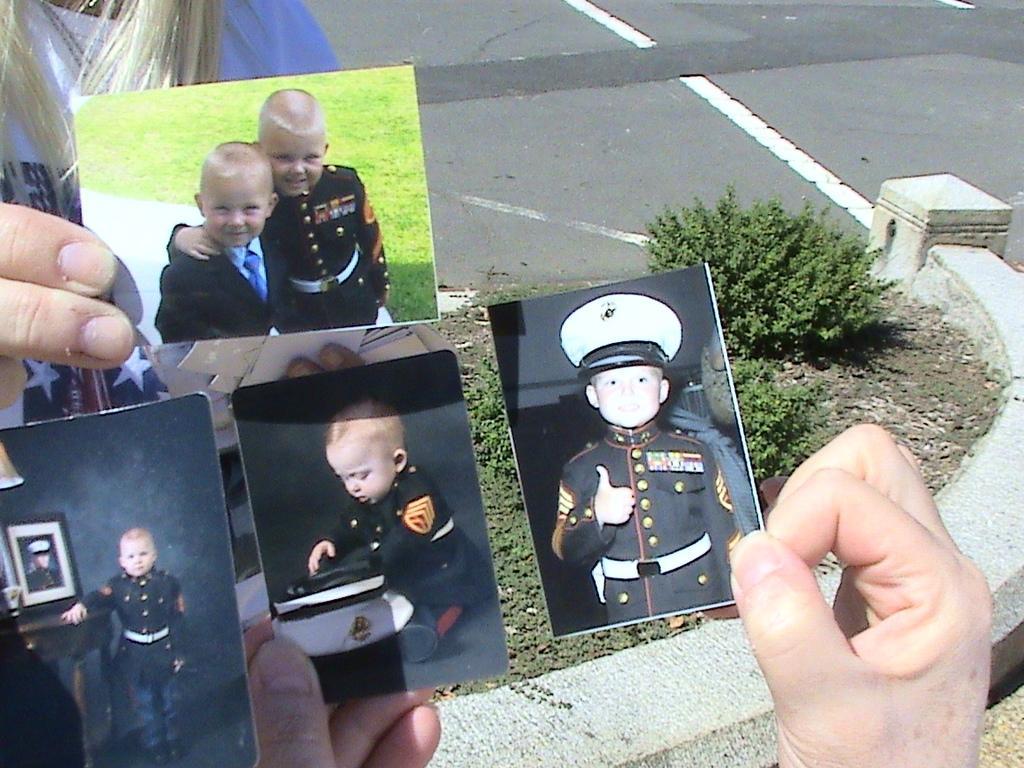Could you give a brief overview of what you see in this image? In this image there are two persons holding photographs of children in their hands, on the surface we can see baby plants. 